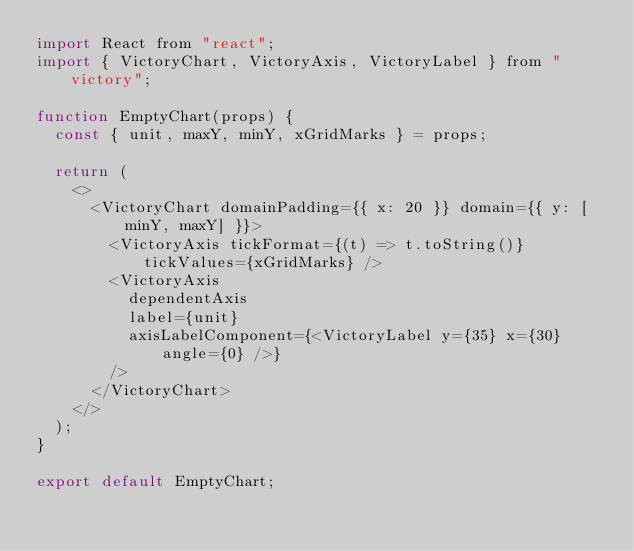<code> <loc_0><loc_0><loc_500><loc_500><_JavaScript_>import React from "react";
import { VictoryChart, VictoryAxis, VictoryLabel } from "victory";

function EmptyChart(props) {
  const { unit, maxY, minY, xGridMarks } = props;

  return (
    <>
      <VictoryChart domainPadding={{ x: 20 }} domain={{ y: [minY, maxY] }}>
        <VictoryAxis tickFormat={(t) => t.toString()} tickValues={xGridMarks} />
        <VictoryAxis
          dependentAxis
          label={unit}
          axisLabelComponent={<VictoryLabel y={35} x={30} angle={0} />}
        />
      </VictoryChart>
    </>
  );
}

export default EmptyChart;
</code> 